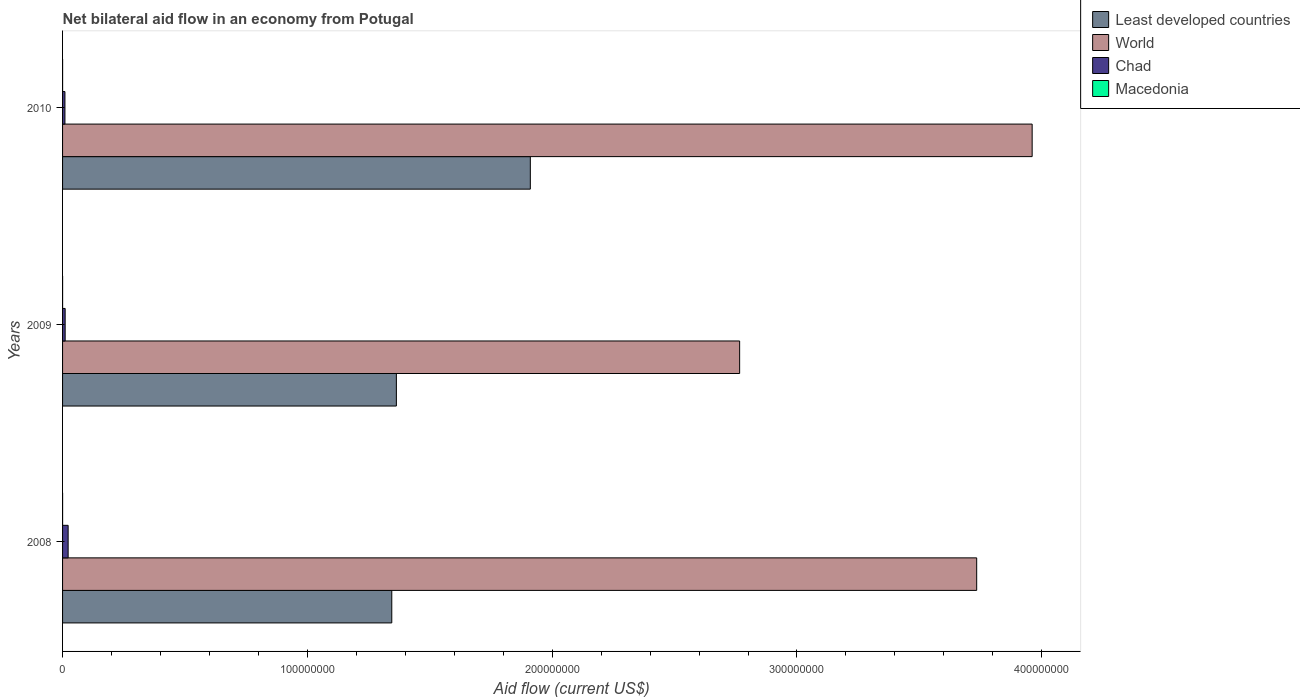How many different coloured bars are there?
Provide a short and direct response. 4. How many groups of bars are there?
Offer a terse response. 3. How many bars are there on the 1st tick from the bottom?
Offer a terse response. 4. What is the net bilateral aid flow in Chad in 2009?
Keep it short and to the point. 1.06e+06. Across all years, what is the maximum net bilateral aid flow in Chad?
Ensure brevity in your answer.  2.28e+06. Across all years, what is the minimum net bilateral aid flow in Chad?
Provide a succinct answer. 9.70e+05. In which year was the net bilateral aid flow in World maximum?
Your response must be concise. 2010. What is the total net bilateral aid flow in Chad in the graph?
Your answer should be very brief. 4.31e+06. What is the difference between the net bilateral aid flow in World in 2010 and the net bilateral aid flow in Macedonia in 2008?
Give a very brief answer. 3.96e+08. In the year 2010, what is the difference between the net bilateral aid flow in Chad and net bilateral aid flow in Macedonia?
Your answer should be very brief. 9.60e+05. In how many years, is the net bilateral aid flow in Chad greater than 200000000 US$?
Your answer should be very brief. 0. What is the ratio of the net bilateral aid flow in World in 2008 to that in 2010?
Provide a succinct answer. 0.94. Is the net bilateral aid flow in Macedonia in 2009 less than that in 2010?
Your response must be concise. No. Is the difference between the net bilateral aid flow in Chad in 2008 and 2009 greater than the difference between the net bilateral aid flow in Macedonia in 2008 and 2009?
Give a very brief answer. Yes. What is the difference between the highest and the second highest net bilateral aid flow in Least developed countries?
Keep it short and to the point. 5.47e+07. What is the difference between the highest and the lowest net bilateral aid flow in Least developed countries?
Ensure brevity in your answer.  5.66e+07. Is the sum of the net bilateral aid flow in Chad in 2008 and 2009 greater than the maximum net bilateral aid flow in World across all years?
Offer a terse response. No. What does the 3rd bar from the bottom in 2010 represents?
Your response must be concise. Chad. How many bars are there?
Provide a short and direct response. 12. Does the graph contain grids?
Your answer should be compact. No. How many legend labels are there?
Your answer should be compact. 4. How are the legend labels stacked?
Give a very brief answer. Vertical. What is the title of the graph?
Your response must be concise. Net bilateral aid flow in an economy from Potugal. Does "Swaziland" appear as one of the legend labels in the graph?
Offer a very short reply. No. What is the label or title of the Y-axis?
Offer a terse response. Years. What is the Aid flow (current US$) in Least developed countries in 2008?
Keep it short and to the point. 1.34e+08. What is the Aid flow (current US$) in World in 2008?
Keep it short and to the point. 3.73e+08. What is the Aid flow (current US$) in Chad in 2008?
Make the answer very short. 2.28e+06. What is the Aid flow (current US$) in Macedonia in 2008?
Offer a very short reply. 10000. What is the Aid flow (current US$) in Least developed countries in 2009?
Provide a succinct answer. 1.36e+08. What is the Aid flow (current US$) of World in 2009?
Your response must be concise. 2.77e+08. What is the Aid flow (current US$) of Chad in 2009?
Give a very brief answer. 1.06e+06. What is the Aid flow (current US$) in Least developed countries in 2010?
Provide a short and direct response. 1.91e+08. What is the Aid flow (current US$) of World in 2010?
Make the answer very short. 3.96e+08. What is the Aid flow (current US$) in Chad in 2010?
Your answer should be very brief. 9.70e+05. Across all years, what is the maximum Aid flow (current US$) of Least developed countries?
Offer a terse response. 1.91e+08. Across all years, what is the maximum Aid flow (current US$) in World?
Provide a short and direct response. 3.96e+08. Across all years, what is the maximum Aid flow (current US$) of Chad?
Offer a terse response. 2.28e+06. Across all years, what is the minimum Aid flow (current US$) in Least developed countries?
Your answer should be very brief. 1.34e+08. Across all years, what is the minimum Aid flow (current US$) in World?
Provide a short and direct response. 2.77e+08. Across all years, what is the minimum Aid flow (current US$) of Chad?
Make the answer very short. 9.70e+05. Across all years, what is the minimum Aid flow (current US$) in Macedonia?
Make the answer very short. 10000. What is the total Aid flow (current US$) of Least developed countries in the graph?
Make the answer very short. 4.62e+08. What is the total Aid flow (current US$) of World in the graph?
Offer a very short reply. 1.05e+09. What is the total Aid flow (current US$) in Chad in the graph?
Your answer should be compact. 4.31e+06. What is the difference between the Aid flow (current US$) of Least developed countries in 2008 and that in 2009?
Offer a very short reply. -1.88e+06. What is the difference between the Aid flow (current US$) in World in 2008 and that in 2009?
Give a very brief answer. 9.68e+07. What is the difference between the Aid flow (current US$) in Chad in 2008 and that in 2009?
Keep it short and to the point. 1.22e+06. What is the difference between the Aid flow (current US$) of Macedonia in 2008 and that in 2009?
Your response must be concise. 0. What is the difference between the Aid flow (current US$) of Least developed countries in 2008 and that in 2010?
Give a very brief answer. -5.66e+07. What is the difference between the Aid flow (current US$) of World in 2008 and that in 2010?
Ensure brevity in your answer.  -2.27e+07. What is the difference between the Aid flow (current US$) of Chad in 2008 and that in 2010?
Your answer should be compact. 1.31e+06. What is the difference between the Aid flow (current US$) in Macedonia in 2008 and that in 2010?
Your answer should be compact. 0. What is the difference between the Aid flow (current US$) of Least developed countries in 2009 and that in 2010?
Offer a very short reply. -5.47e+07. What is the difference between the Aid flow (current US$) of World in 2009 and that in 2010?
Offer a terse response. -1.19e+08. What is the difference between the Aid flow (current US$) of Least developed countries in 2008 and the Aid flow (current US$) of World in 2009?
Keep it short and to the point. -1.42e+08. What is the difference between the Aid flow (current US$) in Least developed countries in 2008 and the Aid flow (current US$) in Chad in 2009?
Give a very brief answer. 1.33e+08. What is the difference between the Aid flow (current US$) in Least developed countries in 2008 and the Aid flow (current US$) in Macedonia in 2009?
Your response must be concise. 1.34e+08. What is the difference between the Aid flow (current US$) of World in 2008 and the Aid flow (current US$) of Chad in 2009?
Offer a very short reply. 3.72e+08. What is the difference between the Aid flow (current US$) in World in 2008 and the Aid flow (current US$) in Macedonia in 2009?
Your response must be concise. 3.73e+08. What is the difference between the Aid flow (current US$) of Chad in 2008 and the Aid flow (current US$) of Macedonia in 2009?
Your response must be concise. 2.27e+06. What is the difference between the Aid flow (current US$) in Least developed countries in 2008 and the Aid flow (current US$) in World in 2010?
Provide a succinct answer. -2.62e+08. What is the difference between the Aid flow (current US$) in Least developed countries in 2008 and the Aid flow (current US$) in Chad in 2010?
Your answer should be very brief. 1.34e+08. What is the difference between the Aid flow (current US$) of Least developed countries in 2008 and the Aid flow (current US$) of Macedonia in 2010?
Make the answer very short. 1.34e+08. What is the difference between the Aid flow (current US$) of World in 2008 and the Aid flow (current US$) of Chad in 2010?
Offer a terse response. 3.72e+08. What is the difference between the Aid flow (current US$) of World in 2008 and the Aid flow (current US$) of Macedonia in 2010?
Your response must be concise. 3.73e+08. What is the difference between the Aid flow (current US$) in Chad in 2008 and the Aid flow (current US$) in Macedonia in 2010?
Give a very brief answer. 2.27e+06. What is the difference between the Aid flow (current US$) in Least developed countries in 2009 and the Aid flow (current US$) in World in 2010?
Give a very brief answer. -2.60e+08. What is the difference between the Aid flow (current US$) of Least developed countries in 2009 and the Aid flow (current US$) of Chad in 2010?
Provide a succinct answer. 1.35e+08. What is the difference between the Aid flow (current US$) in Least developed countries in 2009 and the Aid flow (current US$) in Macedonia in 2010?
Your answer should be compact. 1.36e+08. What is the difference between the Aid flow (current US$) of World in 2009 and the Aid flow (current US$) of Chad in 2010?
Give a very brief answer. 2.76e+08. What is the difference between the Aid flow (current US$) of World in 2009 and the Aid flow (current US$) of Macedonia in 2010?
Keep it short and to the point. 2.77e+08. What is the difference between the Aid flow (current US$) in Chad in 2009 and the Aid flow (current US$) in Macedonia in 2010?
Offer a very short reply. 1.05e+06. What is the average Aid flow (current US$) of Least developed countries per year?
Ensure brevity in your answer.  1.54e+08. What is the average Aid flow (current US$) in World per year?
Offer a very short reply. 3.49e+08. What is the average Aid flow (current US$) of Chad per year?
Your answer should be compact. 1.44e+06. What is the average Aid flow (current US$) in Macedonia per year?
Your answer should be compact. 10000. In the year 2008, what is the difference between the Aid flow (current US$) in Least developed countries and Aid flow (current US$) in World?
Provide a succinct answer. -2.39e+08. In the year 2008, what is the difference between the Aid flow (current US$) of Least developed countries and Aid flow (current US$) of Chad?
Your response must be concise. 1.32e+08. In the year 2008, what is the difference between the Aid flow (current US$) in Least developed countries and Aid flow (current US$) in Macedonia?
Provide a short and direct response. 1.34e+08. In the year 2008, what is the difference between the Aid flow (current US$) in World and Aid flow (current US$) in Chad?
Give a very brief answer. 3.71e+08. In the year 2008, what is the difference between the Aid flow (current US$) of World and Aid flow (current US$) of Macedonia?
Keep it short and to the point. 3.73e+08. In the year 2008, what is the difference between the Aid flow (current US$) in Chad and Aid flow (current US$) in Macedonia?
Offer a terse response. 2.27e+06. In the year 2009, what is the difference between the Aid flow (current US$) in Least developed countries and Aid flow (current US$) in World?
Give a very brief answer. -1.40e+08. In the year 2009, what is the difference between the Aid flow (current US$) of Least developed countries and Aid flow (current US$) of Chad?
Give a very brief answer. 1.35e+08. In the year 2009, what is the difference between the Aid flow (current US$) of Least developed countries and Aid flow (current US$) of Macedonia?
Offer a very short reply. 1.36e+08. In the year 2009, what is the difference between the Aid flow (current US$) of World and Aid flow (current US$) of Chad?
Provide a short and direct response. 2.76e+08. In the year 2009, what is the difference between the Aid flow (current US$) in World and Aid flow (current US$) in Macedonia?
Offer a terse response. 2.77e+08. In the year 2009, what is the difference between the Aid flow (current US$) of Chad and Aid flow (current US$) of Macedonia?
Provide a succinct answer. 1.05e+06. In the year 2010, what is the difference between the Aid flow (current US$) in Least developed countries and Aid flow (current US$) in World?
Give a very brief answer. -2.05e+08. In the year 2010, what is the difference between the Aid flow (current US$) of Least developed countries and Aid flow (current US$) of Chad?
Provide a succinct answer. 1.90e+08. In the year 2010, what is the difference between the Aid flow (current US$) in Least developed countries and Aid flow (current US$) in Macedonia?
Offer a terse response. 1.91e+08. In the year 2010, what is the difference between the Aid flow (current US$) in World and Aid flow (current US$) in Chad?
Provide a succinct answer. 3.95e+08. In the year 2010, what is the difference between the Aid flow (current US$) of World and Aid flow (current US$) of Macedonia?
Provide a short and direct response. 3.96e+08. In the year 2010, what is the difference between the Aid flow (current US$) in Chad and Aid flow (current US$) in Macedonia?
Keep it short and to the point. 9.60e+05. What is the ratio of the Aid flow (current US$) in Least developed countries in 2008 to that in 2009?
Ensure brevity in your answer.  0.99. What is the ratio of the Aid flow (current US$) of World in 2008 to that in 2009?
Your answer should be very brief. 1.35. What is the ratio of the Aid flow (current US$) of Chad in 2008 to that in 2009?
Make the answer very short. 2.15. What is the ratio of the Aid flow (current US$) in Least developed countries in 2008 to that in 2010?
Offer a terse response. 0.7. What is the ratio of the Aid flow (current US$) in World in 2008 to that in 2010?
Ensure brevity in your answer.  0.94. What is the ratio of the Aid flow (current US$) in Chad in 2008 to that in 2010?
Provide a short and direct response. 2.35. What is the ratio of the Aid flow (current US$) of Least developed countries in 2009 to that in 2010?
Provide a succinct answer. 0.71. What is the ratio of the Aid flow (current US$) of World in 2009 to that in 2010?
Offer a very short reply. 0.7. What is the ratio of the Aid flow (current US$) in Chad in 2009 to that in 2010?
Your answer should be compact. 1.09. What is the ratio of the Aid flow (current US$) of Macedonia in 2009 to that in 2010?
Offer a very short reply. 1. What is the difference between the highest and the second highest Aid flow (current US$) of Least developed countries?
Your answer should be very brief. 5.47e+07. What is the difference between the highest and the second highest Aid flow (current US$) of World?
Offer a very short reply. 2.27e+07. What is the difference between the highest and the second highest Aid flow (current US$) of Chad?
Keep it short and to the point. 1.22e+06. What is the difference between the highest and the lowest Aid flow (current US$) of Least developed countries?
Keep it short and to the point. 5.66e+07. What is the difference between the highest and the lowest Aid flow (current US$) of World?
Provide a short and direct response. 1.19e+08. What is the difference between the highest and the lowest Aid flow (current US$) in Chad?
Provide a succinct answer. 1.31e+06. 